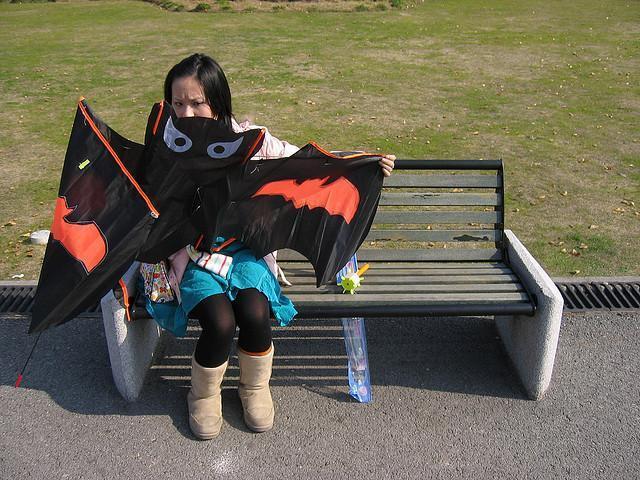How many knives to the left?
Give a very brief answer. 0. 